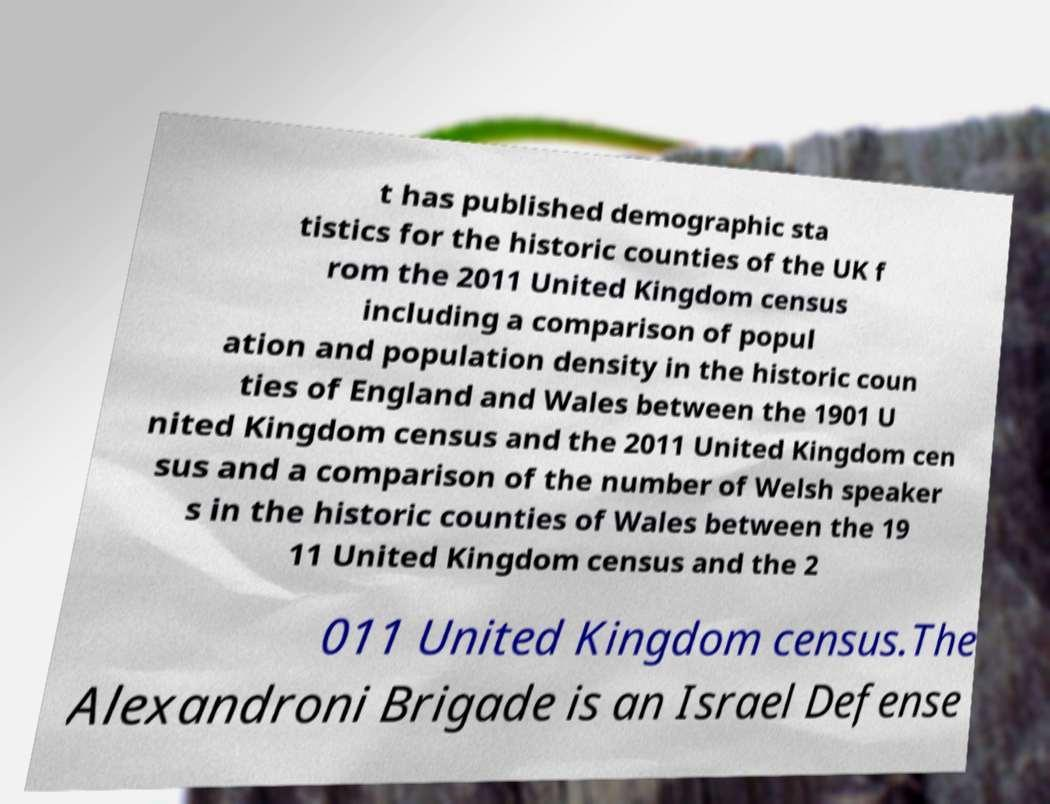Can you read and provide the text displayed in the image?This photo seems to have some interesting text. Can you extract and type it out for me? t has published demographic sta tistics for the historic counties of the UK f rom the 2011 United Kingdom census including a comparison of popul ation and population density in the historic coun ties of England and Wales between the 1901 U nited Kingdom census and the 2011 United Kingdom cen sus and a comparison of the number of Welsh speaker s in the historic counties of Wales between the 19 11 United Kingdom census and the 2 011 United Kingdom census.The Alexandroni Brigade is an Israel Defense 